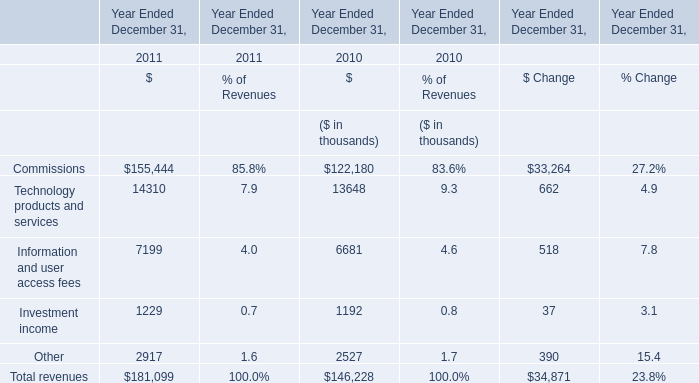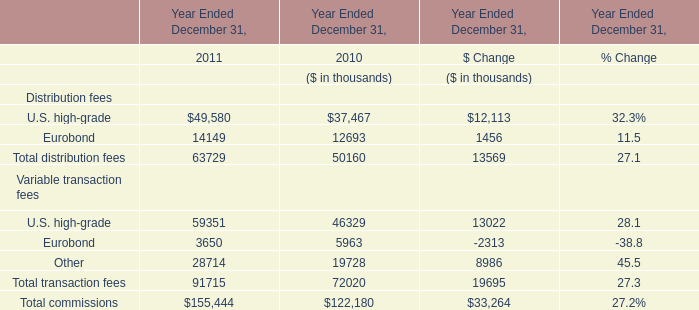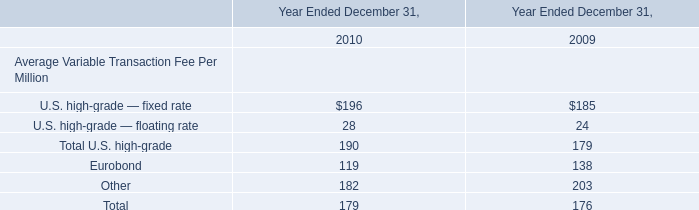In which year is Commissions greater than 150000 ? 
Answer: 2011. 